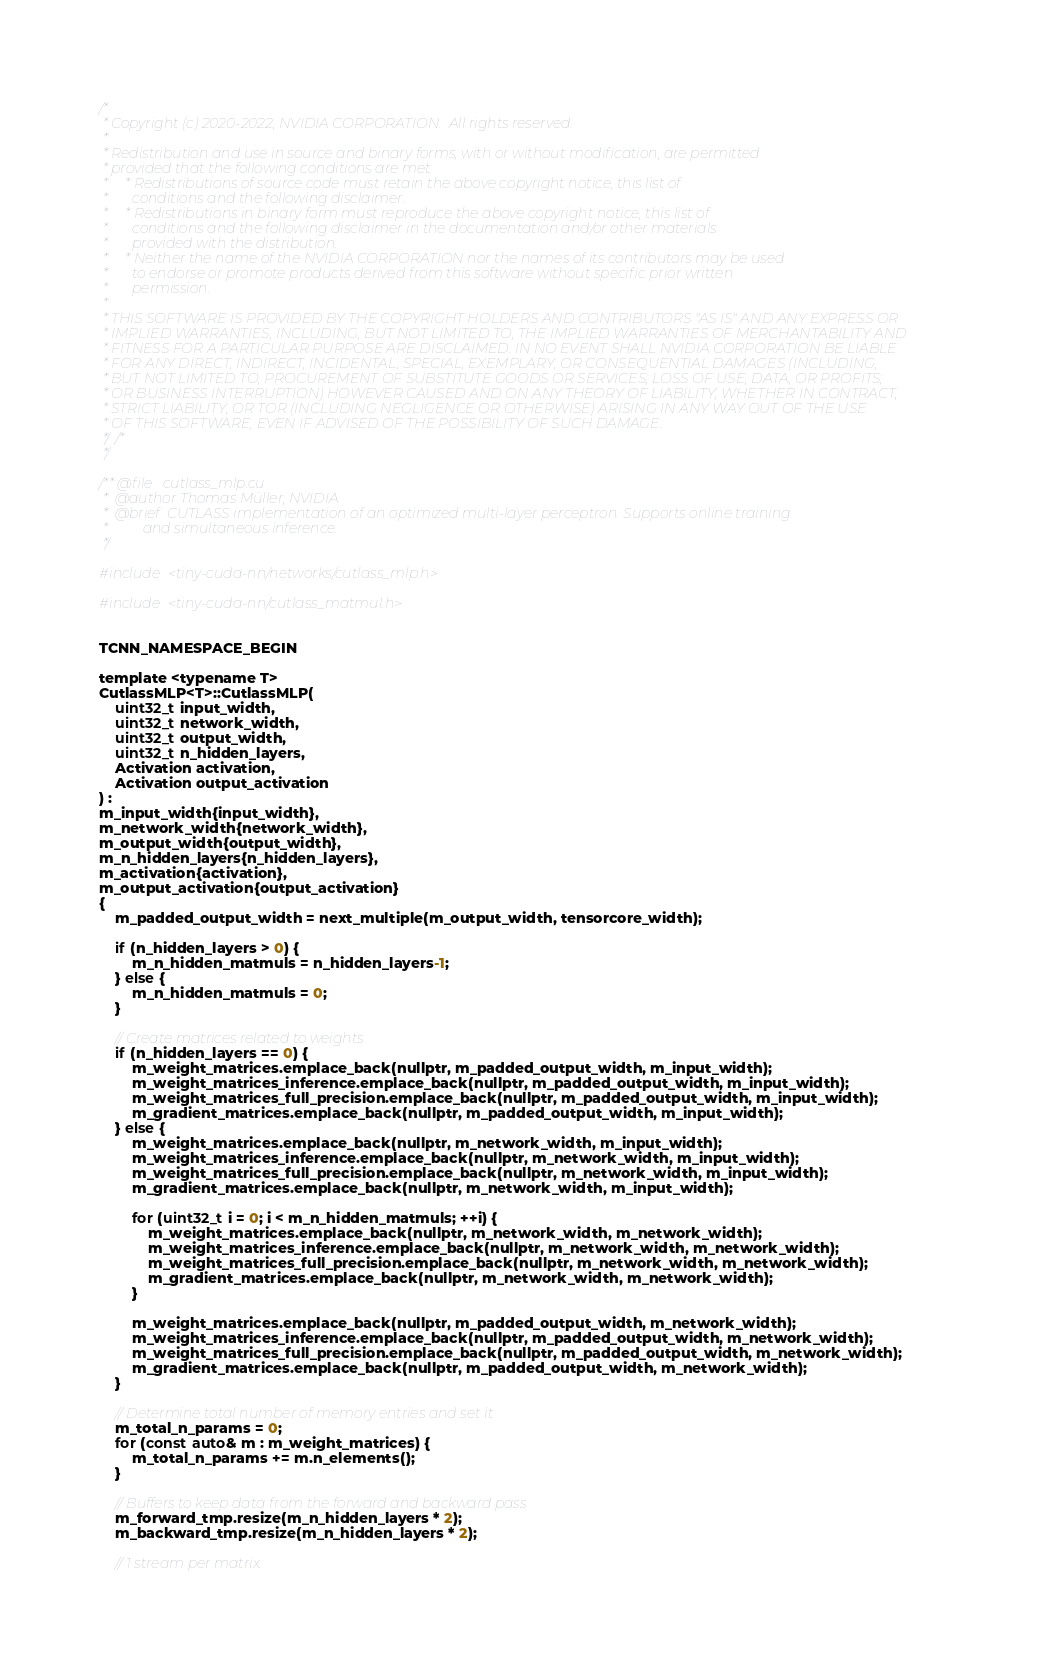Convert code to text. <code><loc_0><loc_0><loc_500><loc_500><_Cuda_>/*
 * Copyright (c) 2020-2022, NVIDIA CORPORATION.  All rights reserved.
 * 
 * Redistribution and use in source and binary forms, with or without modification, are permitted
 * provided that the following conditions are met:
 *     * Redistributions of source code must retain the above copyright notice, this list of
 *       conditions and the following disclaimer.
 *     * Redistributions in binary form must reproduce the above copyright notice, this list of
 *       conditions and the following disclaimer in the documentation and/or other materials
 *       provided with the distribution.
 *     * Neither the name of the NVIDIA CORPORATION nor the names of its contributors may be used
 *       to endorse or promote products derived from this software without specific prior written
 *       permission.
 * 
 * THIS SOFTWARE IS PROVIDED BY THE COPYRIGHT HOLDERS AND CONTRIBUTORS "AS IS" AND ANY EXPRESS OR
 * IMPLIED WARRANTIES, INCLUDING, BUT NOT LIMITED TO, THE IMPLIED WARRANTIES OF MERCHANTABILITY AND
 * FITNESS FOR A PARTICULAR PURPOSE ARE DISCLAIMED. IN NO EVENT SHALL NVIDIA CORPORATION BE LIABLE
 * FOR ANY DIRECT, INDIRECT, INCIDENTAL, SPECIAL, EXEMPLARY, OR CONSEQUENTIAL DAMAGES (INCLUDING,
 * BUT NOT LIMITED TO, PROCUREMENT OF SUBSTITUTE GOODS OR SERVICES; LOSS OF USE, DATA, OR PROFITS;
 * OR BUSINESS INTERRUPTION) HOWEVER CAUSED AND ON ANY THEORY OF LIABILITY, WHETHER IN CONTRACT,
 * STRICT LIABILITY, OR TOR (INCLUDING NEGLIGENCE OR OTHERWISE) ARISING IN ANY WAY OUT OF THE USE
 * OF THIS SOFTWARE, EVEN IF ADVISED OF THE POSSIBILITY OF SUCH DAMAGE.
 *//*
 */

/** @file   cutlass_mlp.cu
 *  @author Thomas Müller, NVIDIA
 *  @brief  CUTLASS implementation of an optimized multi-layer perceptron. Supports online training
 *          and simultaneous inference.
 */

#include <tiny-cuda-nn/networks/cutlass_mlp.h>

#include <tiny-cuda-nn/cutlass_matmul.h>


TCNN_NAMESPACE_BEGIN

template <typename T>
CutlassMLP<T>::CutlassMLP(
	uint32_t input_width,
	uint32_t network_width,
	uint32_t output_width,
	uint32_t n_hidden_layers,
	Activation activation,
	Activation output_activation
) :
m_input_width{input_width},
m_network_width{network_width},
m_output_width{output_width},
m_n_hidden_layers{n_hidden_layers},
m_activation{activation},
m_output_activation{output_activation}
{
	m_padded_output_width = next_multiple(m_output_width, tensorcore_width);

	if (n_hidden_layers > 0) {
		m_n_hidden_matmuls = n_hidden_layers-1;
	} else {
		m_n_hidden_matmuls = 0;
	}

	// Create matrices related to weights
	if (n_hidden_layers == 0) {
		m_weight_matrices.emplace_back(nullptr, m_padded_output_width, m_input_width);
		m_weight_matrices_inference.emplace_back(nullptr, m_padded_output_width, m_input_width);
		m_weight_matrices_full_precision.emplace_back(nullptr, m_padded_output_width, m_input_width);
		m_gradient_matrices.emplace_back(nullptr, m_padded_output_width, m_input_width);
	} else {
		m_weight_matrices.emplace_back(nullptr, m_network_width, m_input_width);
		m_weight_matrices_inference.emplace_back(nullptr, m_network_width, m_input_width);
		m_weight_matrices_full_precision.emplace_back(nullptr, m_network_width, m_input_width);
		m_gradient_matrices.emplace_back(nullptr, m_network_width, m_input_width);

		for (uint32_t i = 0; i < m_n_hidden_matmuls; ++i) {
			m_weight_matrices.emplace_back(nullptr, m_network_width, m_network_width);
			m_weight_matrices_inference.emplace_back(nullptr, m_network_width, m_network_width);
			m_weight_matrices_full_precision.emplace_back(nullptr, m_network_width, m_network_width);
			m_gradient_matrices.emplace_back(nullptr, m_network_width, m_network_width);
		}

		m_weight_matrices.emplace_back(nullptr, m_padded_output_width, m_network_width);
		m_weight_matrices_inference.emplace_back(nullptr, m_padded_output_width, m_network_width);
		m_weight_matrices_full_precision.emplace_back(nullptr, m_padded_output_width, m_network_width);
		m_gradient_matrices.emplace_back(nullptr, m_padded_output_width, m_network_width);
	}

	// Determine total number of memory entries and set it
	m_total_n_params = 0;
	for (const auto& m : m_weight_matrices) {
		m_total_n_params += m.n_elements();
	}

	// Buffers to keep data from the forward and backward pass
	m_forward_tmp.resize(m_n_hidden_layers * 2);
	m_backward_tmp.resize(m_n_hidden_layers * 2);

	// 1 stream per matrix.</code> 